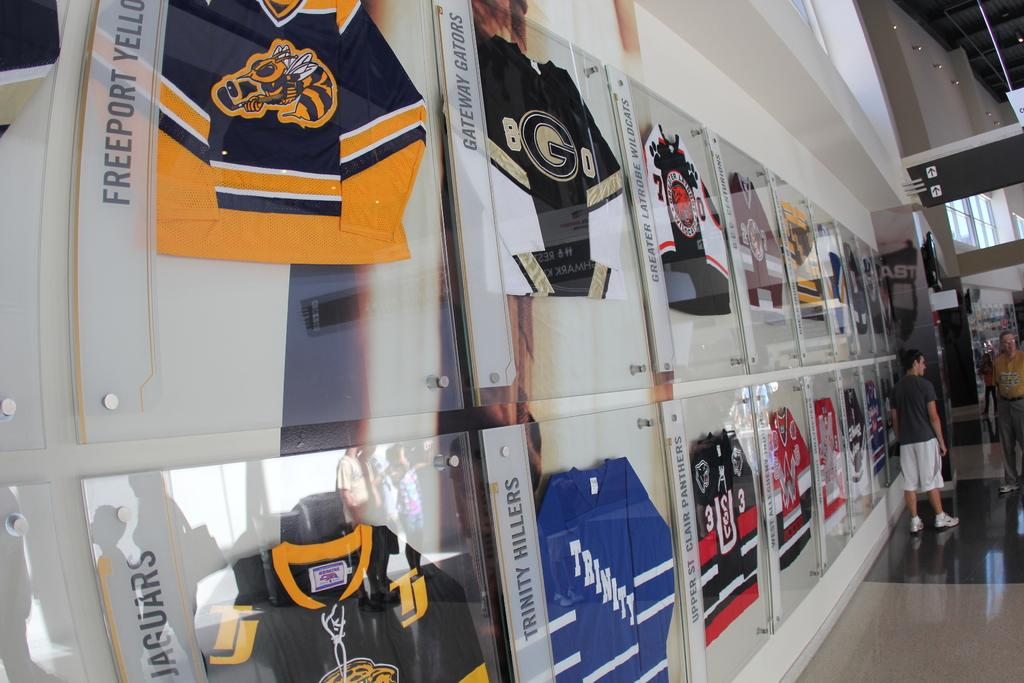<image>
Render a clear and concise summary of the photo. wall with displays of jerseys for teams such as gateway gators, trinity hillers, and upper st clair panthers 